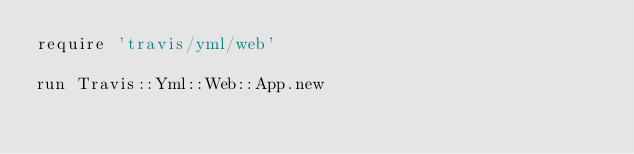<code> <loc_0><loc_0><loc_500><loc_500><_Ruby_>require 'travis/yml/web'

run Travis::Yml::Web::App.new
</code> 